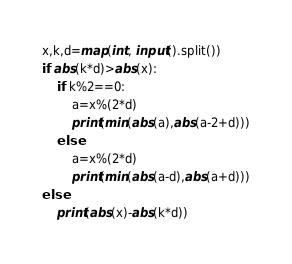<code> <loc_0><loc_0><loc_500><loc_500><_Python_>x,k,d=map(int, input().split())
if abs(k*d)>abs(x):
    if k%2==0:
        a=x%(2*d)
        print(min(abs(a),abs(a-2+d)))
    else:
        a=x%(2*d)
        print(min(abs(a-d),abs(a+d)))
else:
    print(abs(x)-abs(k*d))</code> 